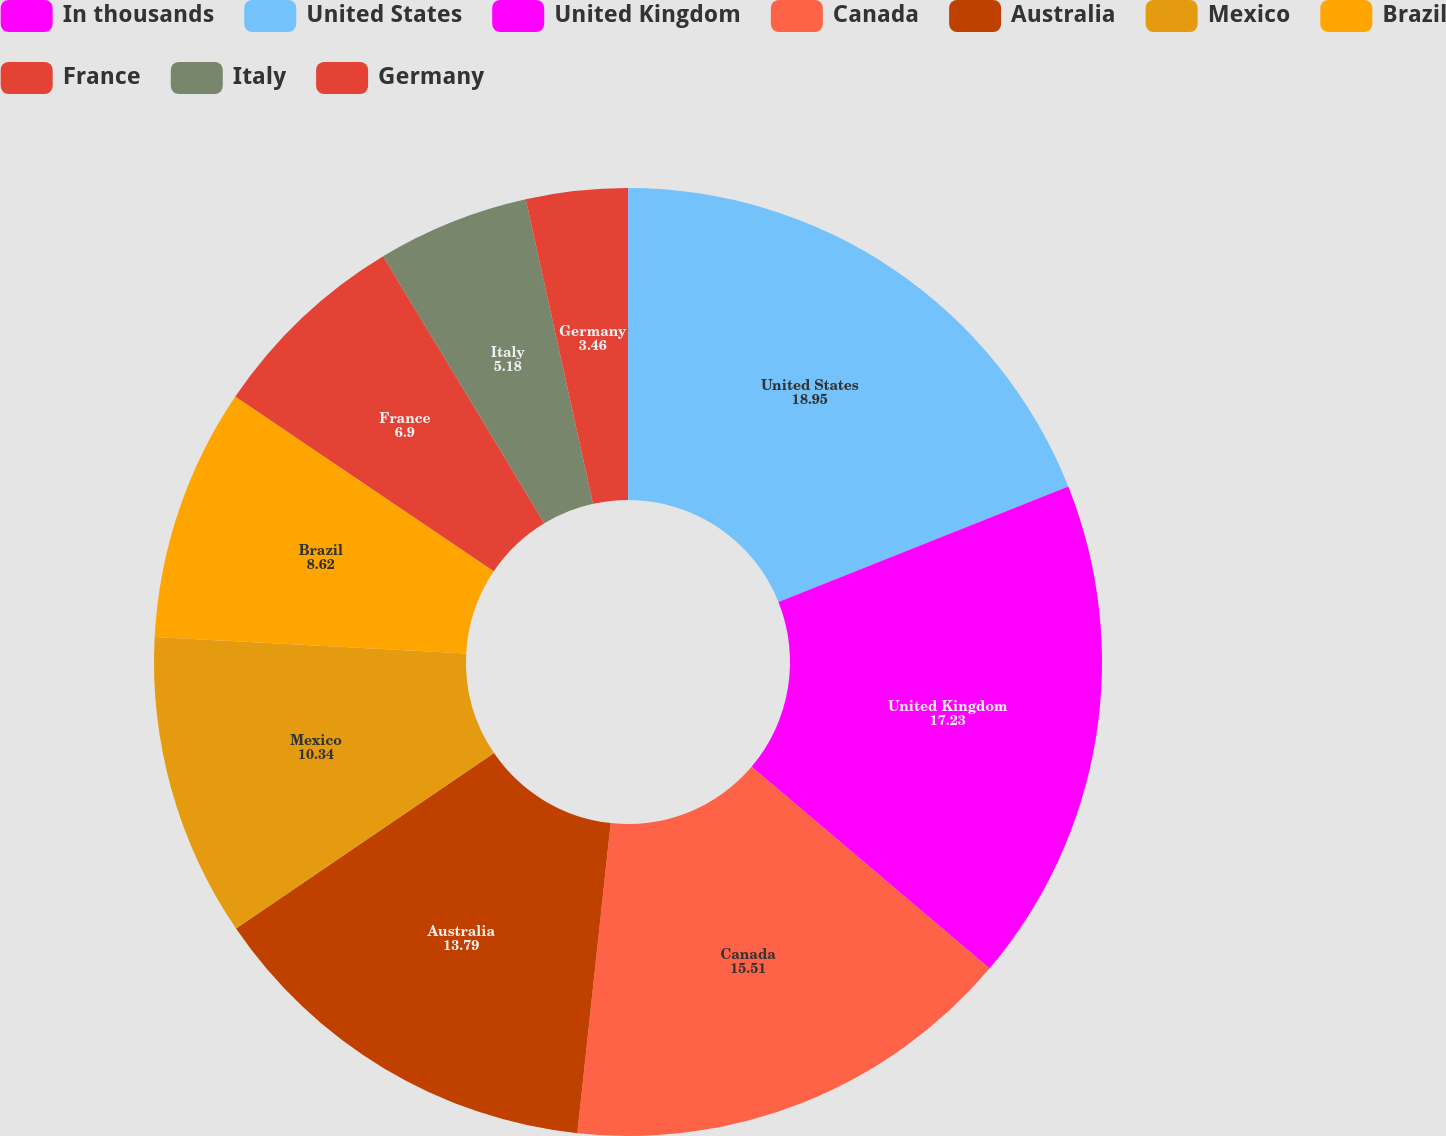<chart> <loc_0><loc_0><loc_500><loc_500><pie_chart><fcel>In thousands<fcel>United States<fcel>United Kingdom<fcel>Canada<fcel>Australia<fcel>Mexico<fcel>Brazil<fcel>France<fcel>Italy<fcel>Germany<nl><fcel>0.01%<fcel>18.95%<fcel>17.23%<fcel>15.51%<fcel>13.79%<fcel>10.34%<fcel>8.62%<fcel>6.9%<fcel>5.18%<fcel>3.46%<nl></chart> 